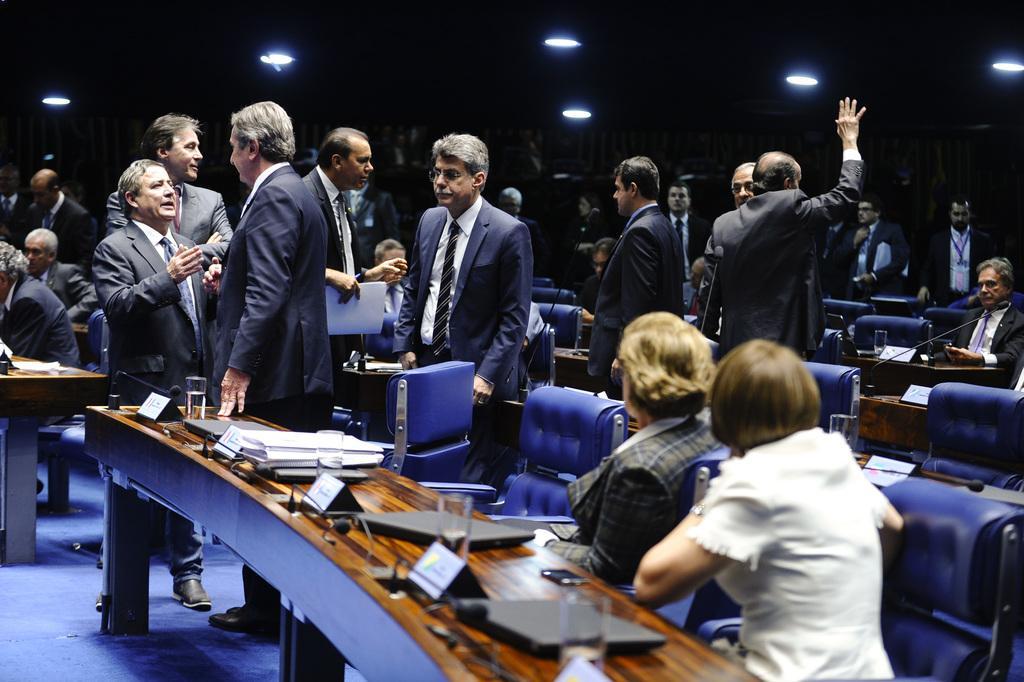Could you give a brief overview of what you see in this image? This image consists of many people. It looks like a conference hall. There are many chairs and tables. The chairs are in blue color. In the front, there are laptops kept on the table along with the bottles and nameplates. In the middle, the men are wearing suit. At the bottom, there is a floor. 